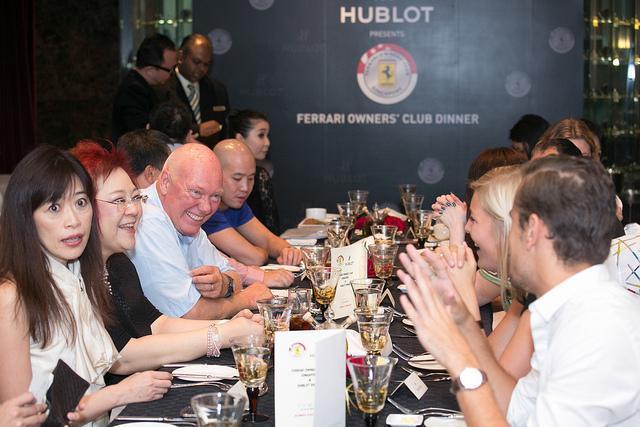How many people are in the image?
Give a very brief answer. 14. How many people can be seen?
Give a very brief answer. 12. How many toothbrushes are seen?
Give a very brief answer. 0. 